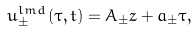Convert formula to latex. <formula><loc_0><loc_0><loc_500><loc_500>u _ { \pm } ^ { l m d } \left ( \tau , t \right ) = A _ { \pm } z + a _ { \pm } \tau ,</formula> 